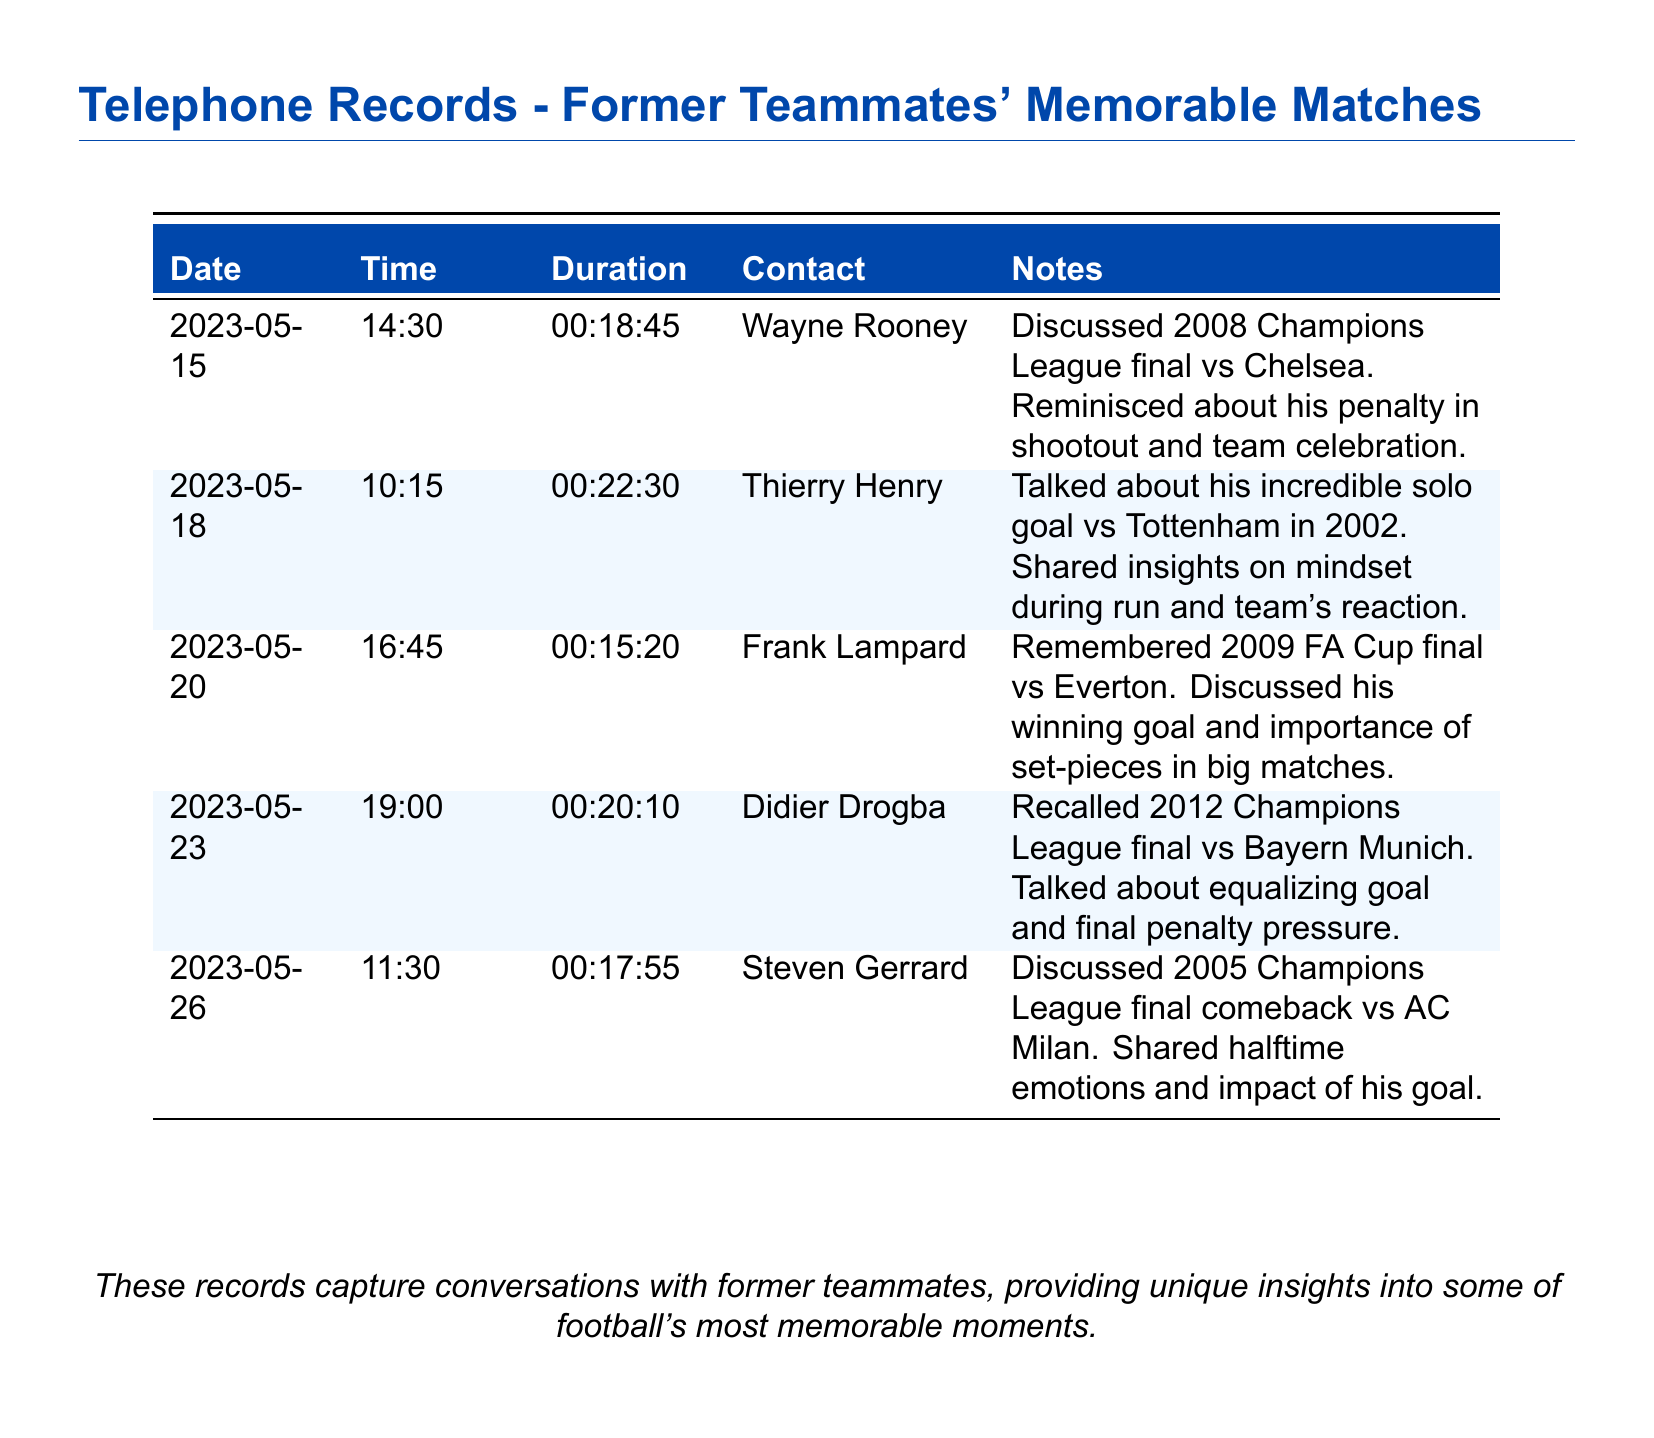What is the date of the call with Wayne Rooney? The call with Wayne Rooney occurred on May 15, 2023, as noted in the document.
Answer: May 15, 2023 What was the duration of the call with Thierry Henry? The duration of the call with Thierry Henry is specified as 22 minutes and 30 seconds in the document.
Answer: 00:22:30 Which match was discussed during the call with Frank Lampard? Frank Lampard discussed the 2009 FA Cup final during their conversation, according to the notes in the document.
Answer: 2009 FA Cup final How long was the call with Didier Drogba? The document states the call with Didier Drogba lasted for 20 minutes and 10 seconds.
Answer: 00:20:10 What memorable goal did Thierry Henry talk about? Thierry Henry talked about his incredible solo goal versus Tottenham in 2002, as per their conversation notes.
Answer: Solo goal vs Tottenham What team did Steven Gerrard discuss in relation to the 2005 Champions League final? Steven Gerrard discussed AC Milan in relation to the 2005 Champions League final during the call.
Answer: AC Milan Which player was mentioned in the context of a penalty shootout? The context of a penalty shootout was mentioned during the call with Wayne Rooney.
Answer: Wayne Rooney How many calls are recorded in total? The document contains a total of five recorded calls with former teammates.
Answer: Five What is the main focus of the telephone records? The main focus of the telephone records is conversations about memorable matches and goals with former teammates.
Answer: Memorable matches and goals 